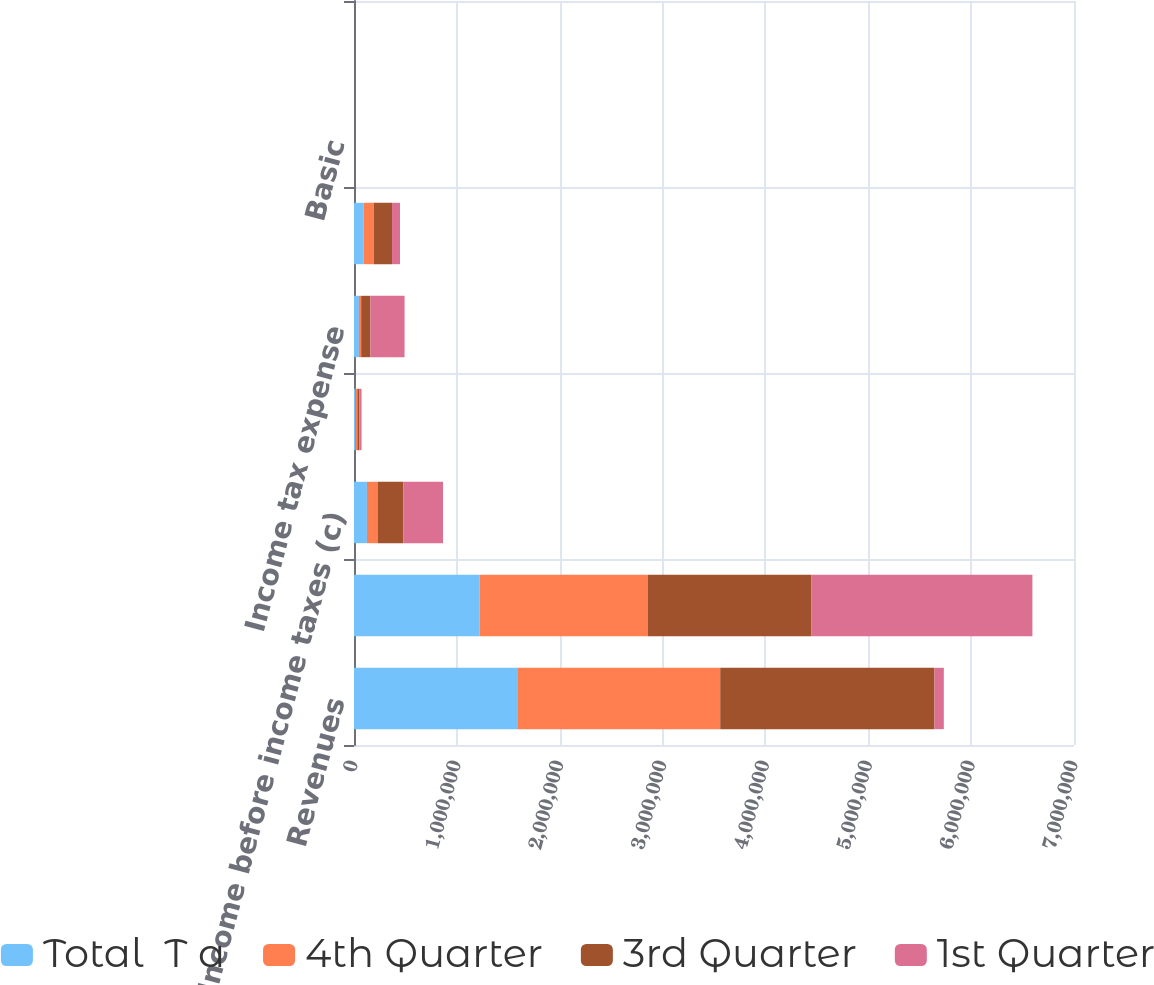Convert chart. <chart><loc_0><loc_0><loc_500><loc_500><stacked_bar_chart><ecel><fcel>Revenues<fcel>Cost of revenues (b)<fcel>Income before income taxes (c)<fcel>Income before income taxes<fcel>Income tax expense<fcel>Net income<fcel>Basic<fcel>Diluted<nl><fcel>Total  T a<fcel>1.58706e+06<fcel>1.22091e+06<fcel>125762<fcel>13503<fcel>47747<fcel>91518<fcel>0.29<fcel>0.28<nl><fcel>4th Quarter<fcel>1.97357e+06<fcel>1.63754e+06<fcel>103599<fcel>18948<fcel>21798<fcel>100749<fcel>0.32<fcel>0.32<nl><fcel>3rd Quarter<fcel>2.08307e+06<fcel>1.58973e+06<fcel>250463<fcel>17786<fcel>90710<fcel>177539<fcel>0.59<fcel>0.58<nl><fcel>1st Quarter<fcel>90710<fcel>2.14743e+06<fcel>385508<fcel>23259<fcel>331352<fcel>77415<fcel>0.26<fcel>0.26<nl></chart> 